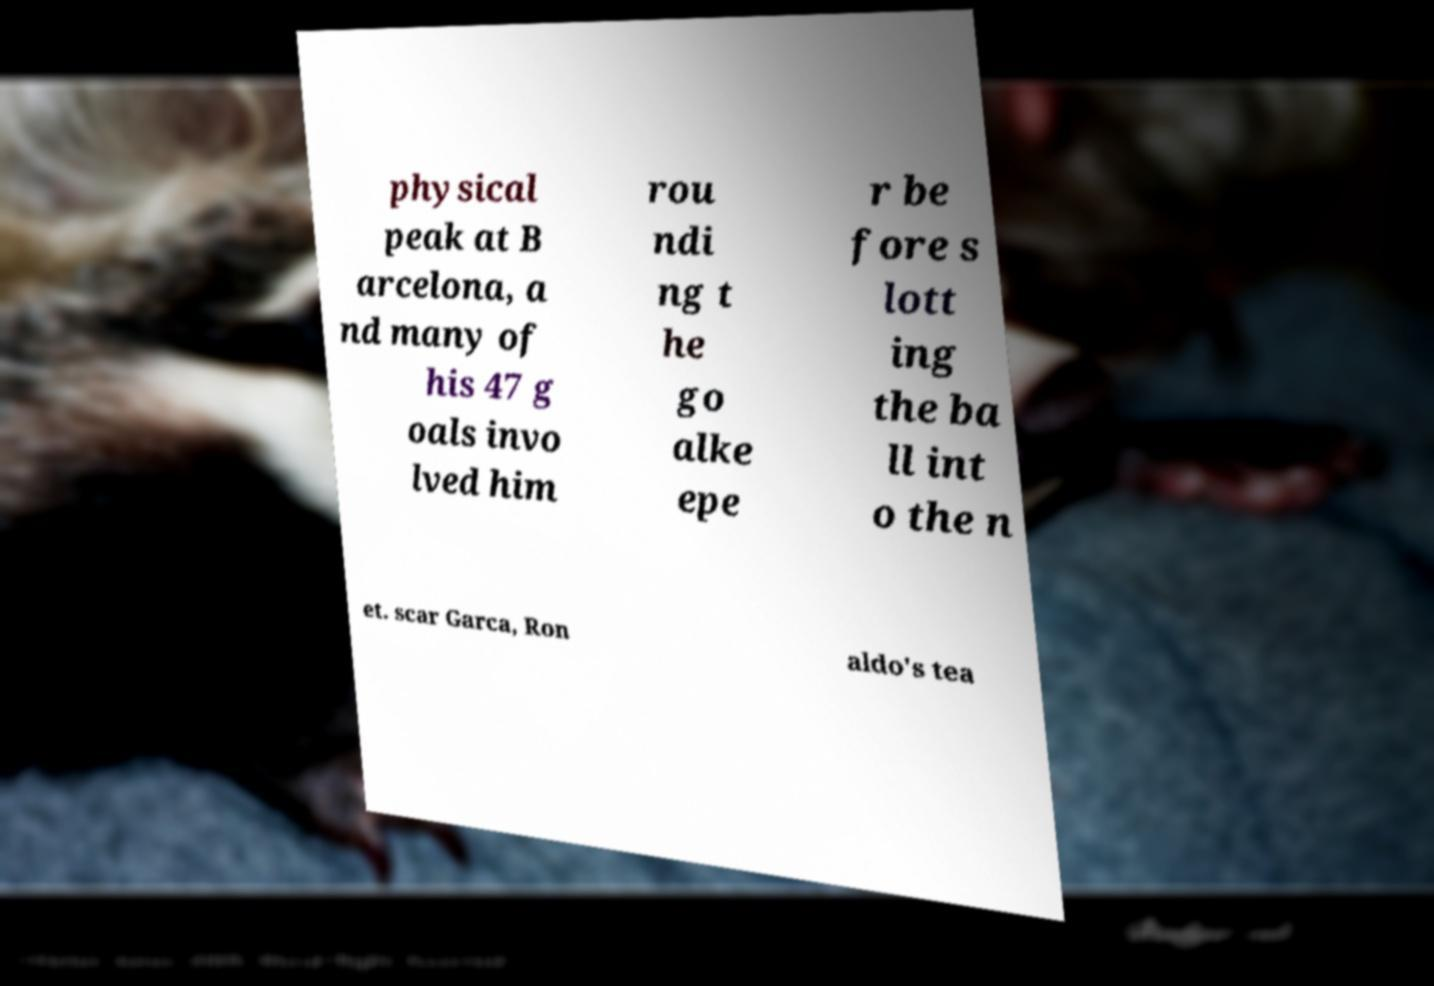What messages or text are displayed in this image? I need them in a readable, typed format. physical peak at B arcelona, a nd many of his 47 g oals invo lved him rou ndi ng t he go alke epe r be fore s lott ing the ba ll int o the n et. scar Garca, Ron aldo's tea 